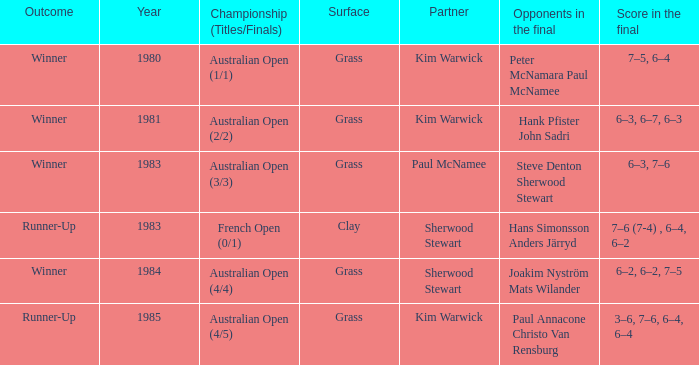What championship was played in 1981? Australian Open (2/2). 